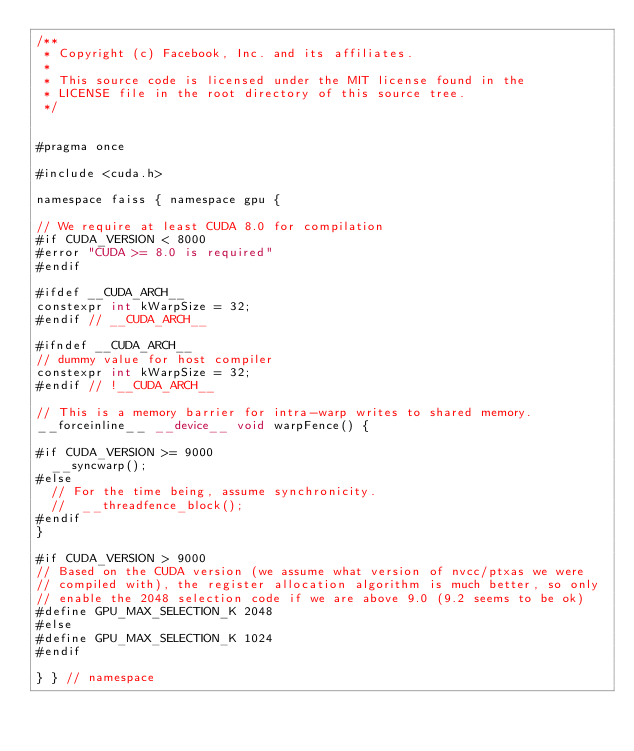Convert code to text. <code><loc_0><loc_0><loc_500><loc_500><_Cuda_>/**
 * Copyright (c) Facebook, Inc. and its affiliates.
 *
 * This source code is licensed under the MIT license found in the
 * LICENSE file in the root directory of this source tree.
 */


#pragma once

#include <cuda.h>

namespace faiss { namespace gpu {

// We require at least CUDA 8.0 for compilation
#if CUDA_VERSION < 8000
#error "CUDA >= 8.0 is required"
#endif

#ifdef __CUDA_ARCH__
constexpr int kWarpSize = 32;
#endif // __CUDA_ARCH__

#ifndef __CUDA_ARCH__
// dummy value for host compiler
constexpr int kWarpSize = 32;
#endif // !__CUDA_ARCH__

// This is a memory barrier for intra-warp writes to shared memory.
__forceinline__ __device__ void warpFence() {

#if CUDA_VERSION >= 9000
  __syncwarp();
#else
  // For the time being, assume synchronicity.
  //  __threadfence_block();
#endif
}

#if CUDA_VERSION > 9000
// Based on the CUDA version (we assume what version of nvcc/ptxas we were
// compiled with), the register allocation algorithm is much better, so only
// enable the 2048 selection code if we are above 9.0 (9.2 seems to be ok)
#define GPU_MAX_SELECTION_K 2048
#else
#define GPU_MAX_SELECTION_K 1024
#endif

} } // namespace
</code> 